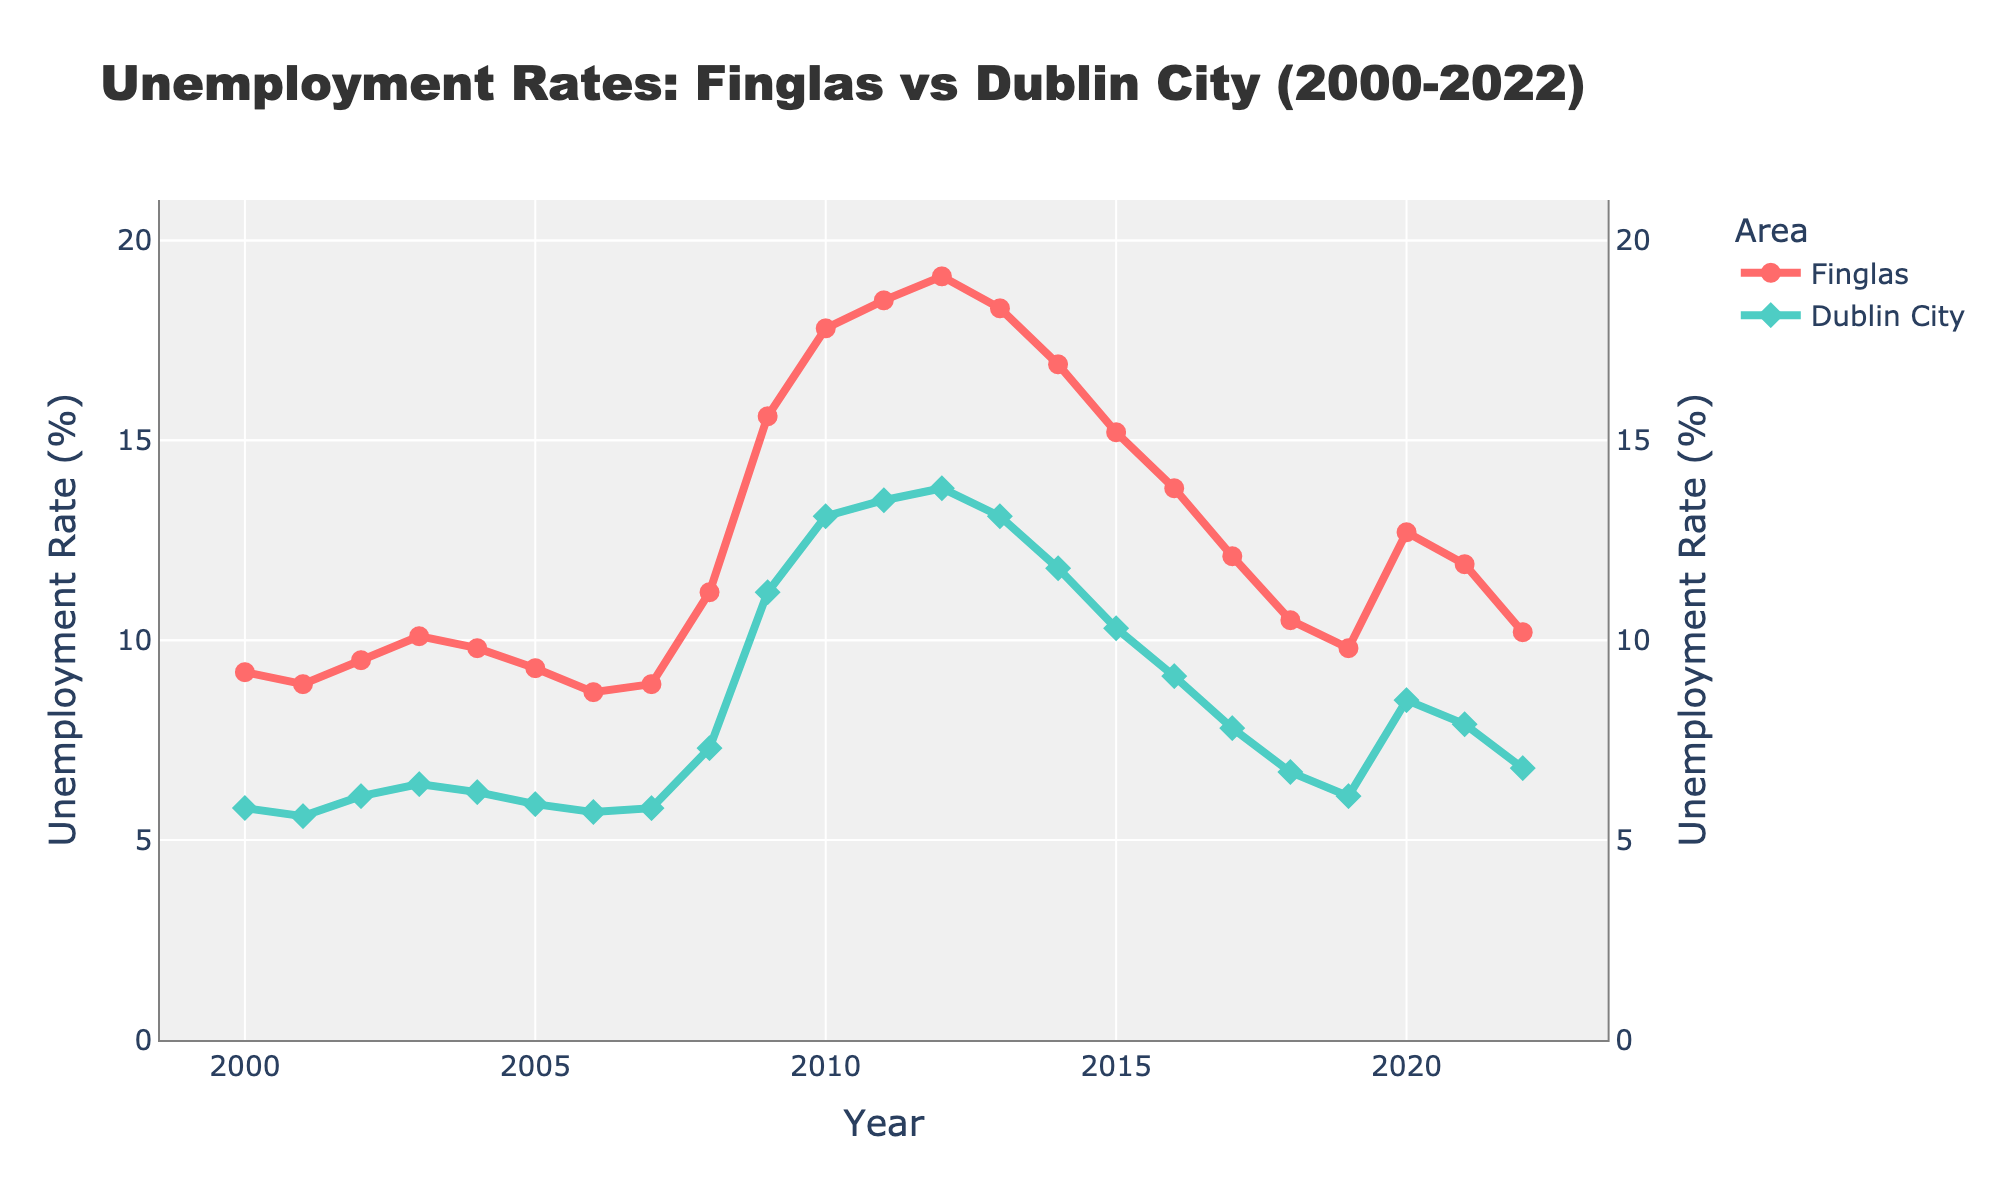What was the unemployment rate in Finglas in 2010? Looking at the data points on the red line (representing Finglas) for the year 2010 will give the unemployment rate.
Answer: 17.8% Which year saw the highest unemployment rate in Finglas? Identify the peak of the red line, which represents the highest point for Finglas unemployment rates.
Answer: 2012 How did the unemployment rates in Finglas compare to Dublin City in 2010? Compare the values of the red line (Finglas) and the green line (Dublin City) for the year 2010. Finglas had a rate of 17.8% and Dublin City had 13.1%.
Answer: Finglas was higher In which years was the unemployment rate higher in Dublin City than in Finglas? Look for any points where the green line (Dublin City) is above the red line (Finglas).
Answer: None What is the difference in unemployment rates between Finglas and Dublin City in 2009? Subtract the value of Dublin City (11.2%) from Finglas (15.6%) for the year 2009.
Answer: 4.4% Which area experienced a larger increase in unemployment rates from 2008 to 2012? Calculate the difference in rates for both areas between these years. Finglas: 19.1% - 11.2% = 7.9%, Dublin City: 13.8% - 7.3% = 6.5%.
Answer: Finglas What color represents the unemployment rate in Finglas? The explanation is based on the visual attributes description, noting the color used for Finglas.
Answer: Red During which years did Dublin City experience a decrease in unemployment rates while Finglas experienced an increase? Identify years by checking when the values of the green line (Dublin City) decrease and the red line (Finglas) increase.
Answer: 2007 to 2008 Between 2016 and 2020, which area had a higher average unemployment rate? Calculate the average rates for both Finglas and Dublin City across those years. Finglas: (13.8% + 12.1% + 10.5% + 9.8% + 12.7%) / 5 = 11.78%, Dublin City: (9.1% + 7.8% + 6.7% + 6.1% + 8.5%) / 5 = 7.64%.
Answer: Finglas What trend do we observe in the unemployment rates in Finglas from 2012 to 2018? Analyze the year-over-year changes in the red line between 2012 and 2018 for continuous observations.
Answer: Gradual decrease 